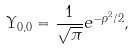<formula> <loc_0><loc_0><loc_500><loc_500>\Upsilon _ { 0 , 0 } = \frac { 1 } { \sqrt { \pi } } e ^ { - \rho ^ { 2 } / 2 } ,</formula> 